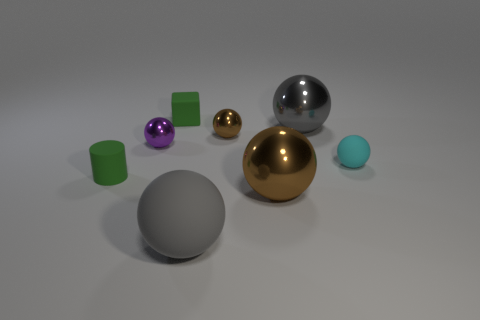Subtract all brown cylinders. How many gray balls are left? 2 Subtract all matte balls. How many balls are left? 4 Add 1 cubes. How many objects exist? 9 Subtract 1 balls. How many balls are left? 5 Subtract all brown balls. How many balls are left? 4 Subtract all blocks. How many objects are left? 7 Subtract all red blocks. Subtract all gray spheres. How many blocks are left? 1 Subtract all gray shiny spheres. Subtract all small blocks. How many objects are left? 6 Add 2 cyan matte spheres. How many cyan matte spheres are left? 3 Add 6 yellow metal spheres. How many yellow metal spheres exist? 6 